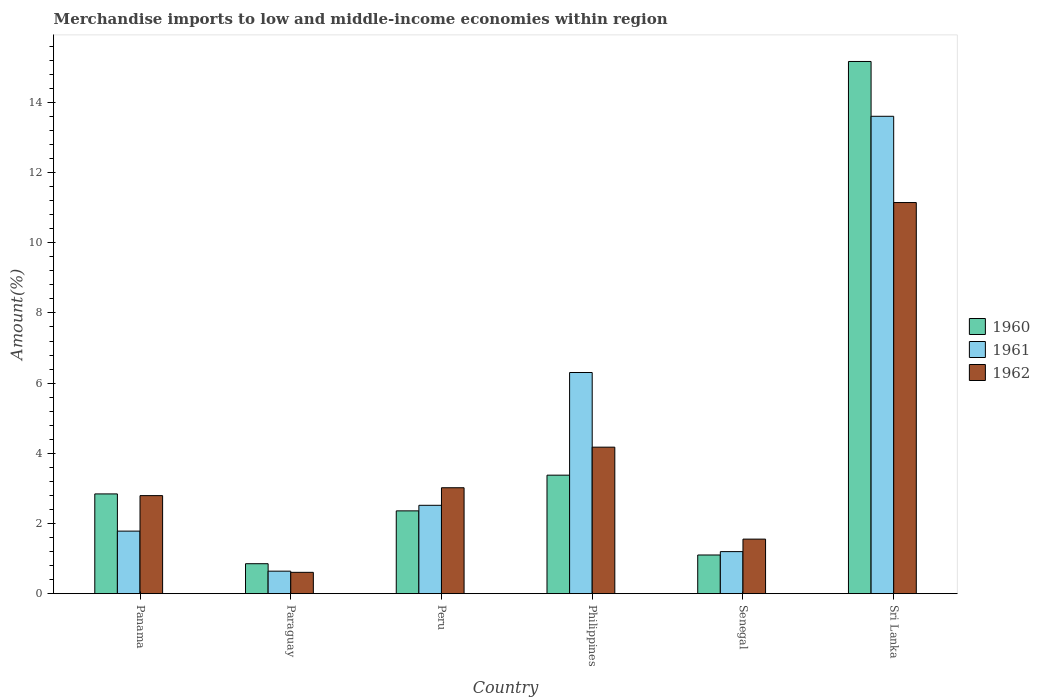How many different coloured bars are there?
Give a very brief answer. 3. What is the label of the 6th group of bars from the left?
Offer a terse response. Sri Lanka. What is the percentage of amount earned from merchandise imports in 1961 in Philippines?
Offer a terse response. 6.3. Across all countries, what is the maximum percentage of amount earned from merchandise imports in 1962?
Ensure brevity in your answer.  11.15. Across all countries, what is the minimum percentage of amount earned from merchandise imports in 1961?
Offer a very short reply. 0.64. In which country was the percentage of amount earned from merchandise imports in 1961 maximum?
Offer a very short reply. Sri Lanka. In which country was the percentage of amount earned from merchandise imports in 1961 minimum?
Your response must be concise. Paraguay. What is the total percentage of amount earned from merchandise imports in 1961 in the graph?
Provide a succinct answer. 26.05. What is the difference between the percentage of amount earned from merchandise imports in 1960 in Panama and that in Philippines?
Give a very brief answer. -0.53. What is the difference between the percentage of amount earned from merchandise imports in 1962 in Peru and the percentage of amount earned from merchandise imports in 1960 in Senegal?
Keep it short and to the point. 1.92. What is the average percentage of amount earned from merchandise imports in 1962 per country?
Offer a very short reply. 3.88. What is the difference between the percentage of amount earned from merchandise imports of/in 1960 and percentage of amount earned from merchandise imports of/in 1961 in Philippines?
Keep it short and to the point. -2.93. In how many countries, is the percentage of amount earned from merchandise imports in 1962 greater than 4.4 %?
Provide a succinct answer. 1. What is the ratio of the percentage of amount earned from merchandise imports in 1960 in Philippines to that in Sri Lanka?
Provide a succinct answer. 0.22. Is the difference between the percentage of amount earned from merchandise imports in 1960 in Panama and Sri Lanka greater than the difference between the percentage of amount earned from merchandise imports in 1961 in Panama and Sri Lanka?
Give a very brief answer. No. What is the difference between the highest and the second highest percentage of amount earned from merchandise imports in 1962?
Offer a very short reply. -8.13. What is the difference between the highest and the lowest percentage of amount earned from merchandise imports in 1961?
Give a very brief answer. 12.96. In how many countries, is the percentage of amount earned from merchandise imports in 1962 greater than the average percentage of amount earned from merchandise imports in 1962 taken over all countries?
Provide a succinct answer. 2. What does the 2nd bar from the left in Sri Lanka represents?
Your answer should be very brief. 1961. Is it the case that in every country, the sum of the percentage of amount earned from merchandise imports in 1961 and percentage of amount earned from merchandise imports in 1960 is greater than the percentage of amount earned from merchandise imports in 1962?
Offer a terse response. Yes. How many bars are there?
Offer a very short reply. 18. Are all the bars in the graph horizontal?
Your response must be concise. No. Are the values on the major ticks of Y-axis written in scientific E-notation?
Provide a short and direct response. No. Where does the legend appear in the graph?
Give a very brief answer. Center right. What is the title of the graph?
Provide a succinct answer. Merchandise imports to low and middle-income economies within region. Does "1987" appear as one of the legend labels in the graph?
Keep it short and to the point. No. What is the label or title of the X-axis?
Provide a succinct answer. Country. What is the label or title of the Y-axis?
Ensure brevity in your answer.  Amount(%). What is the Amount(%) of 1960 in Panama?
Ensure brevity in your answer.  2.84. What is the Amount(%) of 1961 in Panama?
Your response must be concise. 1.78. What is the Amount(%) of 1962 in Panama?
Offer a very short reply. 2.79. What is the Amount(%) in 1960 in Paraguay?
Your response must be concise. 0.85. What is the Amount(%) of 1961 in Paraguay?
Provide a succinct answer. 0.64. What is the Amount(%) of 1962 in Paraguay?
Offer a terse response. 0.61. What is the Amount(%) in 1960 in Peru?
Ensure brevity in your answer.  2.36. What is the Amount(%) in 1961 in Peru?
Give a very brief answer. 2.52. What is the Amount(%) of 1962 in Peru?
Your answer should be very brief. 3.02. What is the Amount(%) of 1960 in Philippines?
Offer a terse response. 3.38. What is the Amount(%) in 1961 in Philippines?
Give a very brief answer. 6.3. What is the Amount(%) in 1962 in Philippines?
Make the answer very short. 4.18. What is the Amount(%) of 1960 in Senegal?
Your answer should be very brief. 1.1. What is the Amount(%) in 1961 in Senegal?
Offer a terse response. 1.2. What is the Amount(%) in 1962 in Senegal?
Offer a terse response. 1.55. What is the Amount(%) in 1960 in Sri Lanka?
Keep it short and to the point. 15.17. What is the Amount(%) of 1961 in Sri Lanka?
Your response must be concise. 13.6. What is the Amount(%) in 1962 in Sri Lanka?
Ensure brevity in your answer.  11.15. Across all countries, what is the maximum Amount(%) of 1960?
Your answer should be very brief. 15.17. Across all countries, what is the maximum Amount(%) in 1961?
Provide a succinct answer. 13.6. Across all countries, what is the maximum Amount(%) of 1962?
Your response must be concise. 11.15. Across all countries, what is the minimum Amount(%) in 1960?
Make the answer very short. 0.85. Across all countries, what is the minimum Amount(%) in 1961?
Ensure brevity in your answer.  0.64. Across all countries, what is the minimum Amount(%) in 1962?
Your answer should be compact. 0.61. What is the total Amount(%) of 1960 in the graph?
Offer a very short reply. 25.7. What is the total Amount(%) in 1961 in the graph?
Ensure brevity in your answer.  26.05. What is the total Amount(%) in 1962 in the graph?
Provide a succinct answer. 23.3. What is the difference between the Amount(%) in 1960 in Panama and that in Paraguay?
Provide a succinct answer. 1.99. What is the difference between the Amount(%) in 1961 in Panama and that in Paraguay?
Make the answer very short. 1.14. What is the difference between the Amount(%) in 1962 in Panama and that in Paraguay?
Give a very brief answer. 2.19. What is the difference between the Amount(%) of 1960 in Panama and that in Peru?
Give a very brief answer. 0.48. What is the difference between the Amount(%) of 1961 in Panama and that in Peru?
Give a very brief answer. -0.74. What is the difference between the Amount(%) in 1962 in Panama and that in Peru?
Your answer should be compact. -0.22. What is the difference between the Amount(%) of 1960 in Panama and that in Philippines?
Your answer should be compact. -0.53. What is the difference between the Amount(%) in 1961 in Panama and that in Philippines?
Your answer should be compact. -4.52. What is the difference between the Amount(%) in 1962 in Panama and that in Philippines?
Your answer should be very brief. -1.38. What is the difference between the Amount(%) in 1960 in Panama and that in Senegal?
Your response must be concise. 1.74. What is the difference between the Amount(%) of 1961 in Panama and that in Senegal?
Offer a terse response. 0.58. What is the difference between the Amount(%) in 1962 in Panama and that in Senegal?
Your answer should be compact. 1.24. What is the difference between the Amount(%) in 1960 in Panama and that in Sri Lanka?
Make the answer very short. -12.32. What is the difference between the Amount(%) of 1961 in Panama and that in Sri Lanka?
Your response must be concise. -11.82. What is the difference between the Amount(%) of 1962 in Panama and that in Sri Lanka?
Ensure brevity in your answer.  -8.35. What is the difference between the Amount(%) in 1960 in Paraguay and that in Peru?
Your response must be concise. -1.51. What is the difference between the Amount(%) in 1961 in Paraguay and that in Peru?
Offer a very short reply. -1.88. What is the difference between the Amount(%) of 1962 in Paraguay and that in Peru?
Provide a succinct answer. -2.41. What is the difference between the Amount(%) in 1960 in Paraguay and that in Philippines?
Make the answer very short. -2.52. What is the difference between the Amount(%) of 1961 in Paraguay and that in Philippines?
Provide a short and direct response. -5.66. What is the difference between the Amount(%) of 1962 in Paraguay and that in Philippines?
Offer a terse response. -3.57. What is the difference between the Amount(%) in 1960 in Paraguay and that in Senegal?
Provide a short and direct response. -0.25. What is the difference between the Amount(%) of 1961 in Paraguay and that in Senegal?
Ensure brevity in your answer.  -0.56. What is the difference between the Amount(%) in 1962 in Paraguay and that in Senegal?
Offer a very short reply. -0.95. What is the difference between the Amount(%) in 1960 in Paraguay and that in Sri Lanka?
Your response must be concise. -14.31. What is the difference between the Amount(%) of 1961 in Paraguay and that in Sri Lanka?
Give a very brief answer. -12.96. What is the difference between the Amount(%) in 1962 in Paraguay and that in Sri Lanka?
Ensure brevity in your answer.  -10.54. What is the difference between the Amount(%) in 1960 in Peru and that in Philippines?
Give a very brief answer. -1.02. What is the difference between the Amount(%) of 1961 in Peru and that in Philippines?
Your response must be concise. -3.78. What is the difference between the Amount(%) of 1962 in Peru and that in Philippines?
Offer a terse response. -1.16. What is the difference between the Amount(%) in 1960 in Peru and that in Senegal?
Provide a short and direct response. 1.26. What is the difference between the Amount(%) of 1961 in Peru and that in Senegal?
Provide a succinct answer. 1.32. What is the difference between the Amount(%) of 1962 in Peru and that in Senegal?
Make the answer very short. 1.46. What is the difference between the Amount(%) of 1960 in Peru and that in Sri Lanka?
Give a very brief answer. -12.81. What is the difference between the Amount(%) in 1961 in Peru and that in Sri Lanka?
Provide a succinct answer. -11.09. What is the difference between the Amount(%) of 1962 in Peru and that in Sri Lanka?
Provide a succinct answer. -8.13. What is the difference between the Amount(%) in 1960 in Philippines and that in Senegal?
Your response must be concise. 2.28. What is the difference between the Amount(%) of 1961 in Philippines and that in Senegal?
Ensure brevity in your answer.  5.1. What is the difference between the Amount(%) in 1962 in Philippines and that in Senegal?
Provide a succinct answer. 2.62. What is the difference between the Amount(%) in 1960 in Philippines and that in Sri Lanka?
Offer a terse response. -11.79. What is the difference between the Amount(%) of 1961 in Philippines and that in Sri Lanka?
Keep it short and to the point. -7.3. What is the difference between the Amount(%) in 1962 in Philippines and that in Sri Lanka?
Your answer should be very brief. -6.97. What is the difference between the Amount(%) in 1960 in Senegal and that in Sri Lanka?
Make the answer very short. -14.06. What is the difference between the Amount(%) of 1961 in Senegal and that in Sri Lanka?
Provide a short and direct response. -12.41. What is the difference between the Amount(%) in 1962 in Senegal and that in Sri Lanka?
Your answer should be compact. -9.59. What is the difference between the Amount(%) of 1960 in Panama and the Amount(%) of 1961 in Paraguay?
Ensure brevity in your answer.  2.2. What is the difference between the Amount(%) in 1960 in Panama and the Amount(%) in 1962 in Paraguay?
Keep it short and to the point. 2.23. What is the difference between the Amount(%) of 1961 in Panama and the Amount(%) of 1962 in Paraguay?
Your answer should be compact. 1.17. What is the difference between the Amount(%) in 1960 in Panama and the Amount(%) in 1961 in Peru?
Your answer should be very brief. 0.32. What is the difference between the Amount(%) of 1960 in Panama and the Amount(%) of 1962 in Peru?
Give a very brief answer. -0.18. What is the difference between the Amount(%) in 1961 in Panama and the Amount(%) in 1962 in Peru?
Ensure brevity in your answer.  -1.24. What is the difference between the Amount(%) of 1960 in Panama and the Amount(%) of 1961 in Philippines?
Offer a very short reply. -3.46. What is the difference between the Amount(%) in 1960 in Panama and the Amount(%) in 1962 in Philippines?
Provide a succinct answer. -1.33. What is the difference between the Amount(%) in 1961 in Panama and the Amount(%) in 1962 in Philippines?
Your response must be concise. -2.39. What is the difference between the Amount(%) in 1960 in Panama and the Amount(%) in 1961 in Senegal?
Provide a short and direct response. 1.64. What is the difference between the Amount(%) in 1960 in Panama and the Amount(%) in 1962 in Senegal?
Give a very brief answer. 1.29. What is the difference between the Amount(%) of 1961 in Panama and the Amount(%) of 1962 in Senegal?
Provide a succinct answer. 0.23. What is the difference between the Amount(%) of 1960 in Panama and the Amount(%) of 1961 in Sri Lanka?
Offer a very short reply. -10.76. What is the difference between the Amount(%) of 1960 in Panama and the Amount(%) of 1962 in Sri Lanka?
Offer a very short reply. -8.3. What is the difference between the Amount(%) in 1961 in Panama and the Amount(%) in 1962 in Sri Lanka?
Provide a short and direct response. -9.36. What is the difference between the Amount(%) of 1960 in Paraguay and the Amount(%) of 1961 in Peru?
Your response must be concise. -1.66. What is the difference between the Amount(%) of 1960 in Paraguay and the Amount(%) of 1962 in Peru?
Give a very brief answer. -2.17. What is the difference between the Amount(%) in 1961 in Paraguay and the Amount(%) in 1962 in Peru?
Offer a terse response. -2.38. What is the difference between the Amount(%) in 1960 in Paraguay and the Amount(%) in 1961 in Philippines?
Offer a very short reply. -5.45. What is the difference between the Amount(%) in 1960 in Paraguay and the Amount(%) in 1962 in Philippines?
Your answer should be compact. -3.32. What is the difference between the Amount(%) in 1961 in Paraguay and the Amount(%) in 1962 in Philippines?
Ensure brevity in your answer.  -3.53. What is the difference between the Amount(%) of 1960 in Paraguay and the Amount(%) of 1961 in Senegal?
Your response must be concise. -0.34. What is the difference between the Amount(%) of 1960 in Paraguay and the Amount(%) of 1962 in Senegal?
Your answer should be compact. -0.7. What is the difference between the Amount(%) in 1961 in Paraguay and the Amount(%) in 1962 in Senegal?
Offer a terse response. -0.91. What is the difference between the Amount(%) of 1960 in Paraguay and the Amount(%) of 1961 in Sri Lanka?
Your answer should be very brief. -12.75. What is the difference between the Amount(%) of 1960 in Paraguay and the Amount(%) of 1962 in Sri Lanka?
Your answer should be compact. -10.29. What is the difference between the Amount(%) in 1961 in Paraguay and the Amount(%) in 1962 in Sri Lanka?
Your answer should be compact. -10.51. What is the difference between the Amount(%) in 1960 in Peru and the Amount(%) in 1961 in Philippines?
Offer a very short reply. -3.94. What is the difference between the Amount(%) of 1960 in Peru and the Amount(%) of 1962 in Philippines?
Your response must be concise. -1.82. What is the difference between the Amount(%) of 1961 in Peru and the Amount(%) of 1962 in Philippines?
Your answer should be very brief. -1.66. What is the difference between the Amount(%) of 1960 in Peru and the Amount(%) of 1961 in Senegal?
Offer a terse response. 1.16. What is the difference between the Amount(%) in 1960 in Peru and the Amount(%) in 1962 in Senegal?
Offer a very short reply. 0.8. What is the difference between the Amount(%) of 1961 in Peru and the Amount(%) of 1962 in Senegal?
Provide a short and direct response. 0.96. What is the difference between the Amount(%) in 1960 in Peru and the Amount(%) in 1961 in Sri Lanka?
Give a very brief answer. -11.24. What is the difference between the Amount(%) of 1960 in Peru and the Amount(%) of 1962 in Sri Lanka?
Make the answer very short. -8.79. What is the difference between the Amount(%) of 1961 in Peru and the Amount(%) of 1962 in Sri Lanka?
Keep it short and to the point. -8.63. What is the difference between the Amount(%) of 1960 in Philippines and the Amount(%) of 1961 in Senegal?
Make the answer very short. 2.18. What is the difference between the Amount(%) in 1960 in Philippines and the Amount(%) in 1962 in Senegal?
Offer a very short reply. 1.82. What is the difference between the Amount(%) of 1961 in Philippines and the Amount(%) of 1962 in Senegal?
Offer a terse response. 4.75. What is the difference between the Amount(%) of 1960 in Philippines and the Amount(%) of 1961 in Sri Lanka?
Provide a succinct answer. -10.23. What is the difference between the Amount(%) of 1960 in Philippines and the Amount(%) of 1962 in Sri Lanka?
Offer a very short reply. -7.77. What is the difference between the Amount(%) of 1961 in Philippines and the Amount(%) of 1962 in Sri Lanka?
Keep it short and to the point. -4.84. What is the difference between the Amount(%) in 1960 in Senegal and the Amount(%) in 1961 in Sri Lanka?
Provide a succinct answer. -12.5. What is the difference between the Amount(%) in 1960 in Senegal and the Amount(%) in 1962 in Sri Lanka?
Ensure brevity in your answer.  -10.04. What is the difference between the Amount(%) of 1961 in Senegal and the Amount(%) of 1962 in Sri Lanka?
Keep it short and to the point. -9.95. What is the average Amount(%) of 1960 per country?
Ensure brevity in your answer.  4.28. What is the average Amount(%) of 1961 per country?
Your response must be concise. 4.34. What is the average Amount(%) of 1962 per country?
Ensure brevity in your answer.  3.88. What is the difference between the Amount(%) of 1960 and Amount(%) of 1961 in Panama?
Make the answer very short. 1.06. What is the difference between the Amount(%) of 1960 and Amount(%) of 1962 in Panama?
Your answer should be very brief. 0.05. What is the difference between the Amount(%) in 1961 and Amount(%) in 1962 in Panama?
Provide a short and direct response. -1.01. What is the difference between the Amount(%) in 1960 and Amount(%) in 1961 in Paraguay?
Your answer should be very brief. 0.21. What is the difference between the Amount(%) in 1960 and Amount(%) in 1962 in Paraguay?
Your response must be concise. 0.25. What is the difference between the Amount(%) in 1961 and Amount(%) in 1962 in Paraguay?
Your answer should be very brief. 0.03. What is the difference between the Amount(%) of 1960 and Amount(%) of 1961 in Peru?
Keep it short and to the point. -0.16. What is the difference between the Amount(%) in 1960 and Amount(%) in 1962 in Peru?
Offer a very short reply. -0.66. What is the difference between the Amount(%) of 1961 and Amount(%) of 1962 in Peru?
Make the answer very short. -0.5. What is the difference between the Amount(%) in 1960 and Amount(%) in 1961 in Philippines?
Give a very brief answer. -2.93. What is the difference between the Amount(%) in 1960 and Amount(%) in 1962 in Philippines?
Offer a terse response. -0.8. What is the difference between the Amount(%) in 1961 and Amount(%) in 1962 in Philippines?
Your response must be concise. 2.13. What is the difference between the Amount(%) of 1960 and Amount(%) of 1961 in Senegal?
Make the answer very short. -0.1. What is the difference between the Amount(%) of 1960 and Amount(%) of 1962 in Senegal?
Provide a succinct answer. -0.45. What is the difference between the Amount(%) in 1961 and Amount(%) in 1962 in Senegal?
Provide a succinct answer. -0.36. What is the difference between the Amount(%) of 1960 and Amount(%) of 1961 in Sri Lanka?
Offer a terse response. 1.56. What is the difference between the Amount(%) in 1960 and Amount(%) in 1962 in Sri Lanka?
Keep it short and to the point. 4.02. What is the difference between the Amount(%) in 1961 and Amount(%) in 1962 in Sri Lanka?
Your answer should be very brief. 2.46. What is the ratio of the Amount(%) in 1960 in Panama to that in Paraguay?
Your answer should be very brief. 3.33. What is the ratio of the Amount(%) in 1961 in Panama to that in Paraguay?
Your response must be concise. 2.78. What is the ratio of the Amount(%) of 1962 in Panama to that in Paraguay?
Offer a terse response. 4.6. What is the ratio of the Amount(%) of 1960 in Panama to that in Peru?
Your answer should be very brief. 1.2. What is the ratio of the Amount(%) of 1961 in Panama to that in Peru?
Your answer should be compact. 0.71. What is the ratio of the Amount(%) in 1962 in Panama to that in Peru?
Give a very brief answer. 0.93. What is the ratio of the Amount(%) in 1960 in Panama to that in Philippines?
Your response must be concise. 0.84. What is the ratio of the Amount(%) of 1961 in Panama to that in Philippines?
Ensure brevity in your answer.  0.28. What is the ratio of the Amount(%) in 1962 in Panama to that in Philippines?
Offer a very short reply. 0.67. What is the ratio of the Amount(%) of 1960 in Panama to that in Senegal?
Provide a short and direct response. 2.58. What is the ratio of the Amount(%) of 1961 in Panama to that in Senegal?
Offer a terse response. 1.49. What is the ratio of the Amount(%) of 1962 in Panama to that in Senegal?
Offer a terse response. 1.8. What is the ratio of the Amount(%) in 1960 in Panama to that in Sri Lanka?
Your answer should be compact. 0.19. What is the ratio of the Amount(%) in 1961 in Panama to that in Sri Lanka?
Your answer should be compact. 0.13. What is the ratio of the Amount(%) of 1962 in Panama to that in Sri Lanka?
Provide a succinct answer. 0.25. What is the ratio of the Amount(%) of 1960 in Paraguay to that in Peru?
Offer a terse response. 0.36. What is the ratio of the Amount(%) in 1961 in Paraguay to that in Peru?
Offer a very short reply. 0.25. What is the ratio of the Amount(%) in 1962 in Paraguay to that in Peru?
Your response must be concise. 0.2. What is the ratio of the Amount(%) of 1960 in Paraguay to that in Philippines?
Your answer should be very brief. 0.25. What is the ratio of the Amount(%) of 1961 in Paraguay to that in Philippines?
Your answer should be very brief. 0.1. What is the ratio of the Amount(%) in 1962 in Paraguay to that in Philippines?
Your answer should be compact. 0.15. What is the ratio of the Amount(%) in 1960 in Paraguay to that in Senegal?
Give a very brief answer. 0.77. What is the ratio of the Amount(%) in 1961 in Paraguay to that in Senegal?
Offer a very short reply. 0.54. What is the ratio of the Amount(%) of 1962 in Paraguay to that in Senegal?
Your answer should be very brief. 0.39. What is the ratio of the Amount(%) of 1960 in Paraguay to that in Sri Lanka?
Give a very brief answer. 0.06. What is the ratio of the Amount(%) of 1961 in Paraguay to that in Sri Lanka?
Provide a succinct answer. 0.05. What is the ratio of the Amount(%) of 1962 in Paraguay to that in Sri Lanka?
Ensure brevity in your answer.  0.05. What is the ratio of the Amount(%) of 1960 in Peru to that in Philippines?
Make the answer very short. 0.7. What is the ratio of the Amount(%) of 1961 in Peru to that in Philippines?
Offer a terse response. 0.4. What is the ratio of the Amount(%) in 1962 in Peru to that in Philippines?
Offer a terse response. 0.72. What is the ratio of the Amount(%) of 1960 in Peru to that in Senegal?
Offer a very short reply. 2.14. What is the ratio of the Amount(%) of 1961 in Peru to that in Senegal?
Offer a terse response. 2.1. What is the ratio of the Amount(%) in 1962 in Peru to that in Senegal?
Offer a terse response. 1.94. What is the ratio of the Amount(%) of 1960 in Peru to that in Sri Lanka?
Give a very brief answer. 0.16. What is the ratio of the Amount(%) in 1961 in Peru to that in Sri Lanka?
Ensure brevity in your answer.  0.19. What is the ratio of the Amount(%) in 1962 in Peru to that in Sri Lanka?
Offer a terse response. 0.27. What is the ratio of the Amount(%) in 1960 in Philippines to that in Senegal?
Provide a succinct answer. 3.06. What is the ratio of the Amount(%) of 1961 in Philippines to that in Senegal?
Make the answer very short. 5.26. What is the ratio of the Amount(%) in 1962 in Philippines to that in Senegal?
Make the answer very short. 2.69. What is the ratio of the Amount(%) of 1960 in Philippines to that in Sri Lanka?
Keep it short and to the point. 0.22. What is the ratio of the Amount(%) of 1961 in Philippines to that in Sri Lanka?
Give a very brief answer. 0.46. What is the ratio of the Amount(%) of 1962 in Philippines to that in Sri Lanka?
Your answer should be compact. 0.37. What is the ratio of the Amount(%) of 1960 in Senegal to that in Sri Lanka?
Provide a short and direct response. 0.07. What is the ratio of the Amount(%) in 1961 in Senegal to that in Sri Lanka?
Your answer should be compact. 0.09. What is the ratio of the Amount(%) of 1962 in Senegal to that in Sri Lanka?
Your answer should be very brief. 0.14. What is the difference between the highest and the second highest Amount(%) of 1960?
Give a very brief answer. 11.79. What is the difference between the highest and the second highest Amount(%) in 1961?
Offer a very short reply. 7.3. What is the difference between the highest and the second highest Amount(%) of 1962?
Make the answer very short. 6.97. What is the difference between the highest and the lowest Amount(%) in 1960?
Your response must be concise. 14.31. What is the difference between the highest and the lowest Amount(%) of 1961?
Offer a terse response. 12.96. What is the difference between the highest and the lowest Amount(%) in 1962?
Your response must be concise. 10.54. 